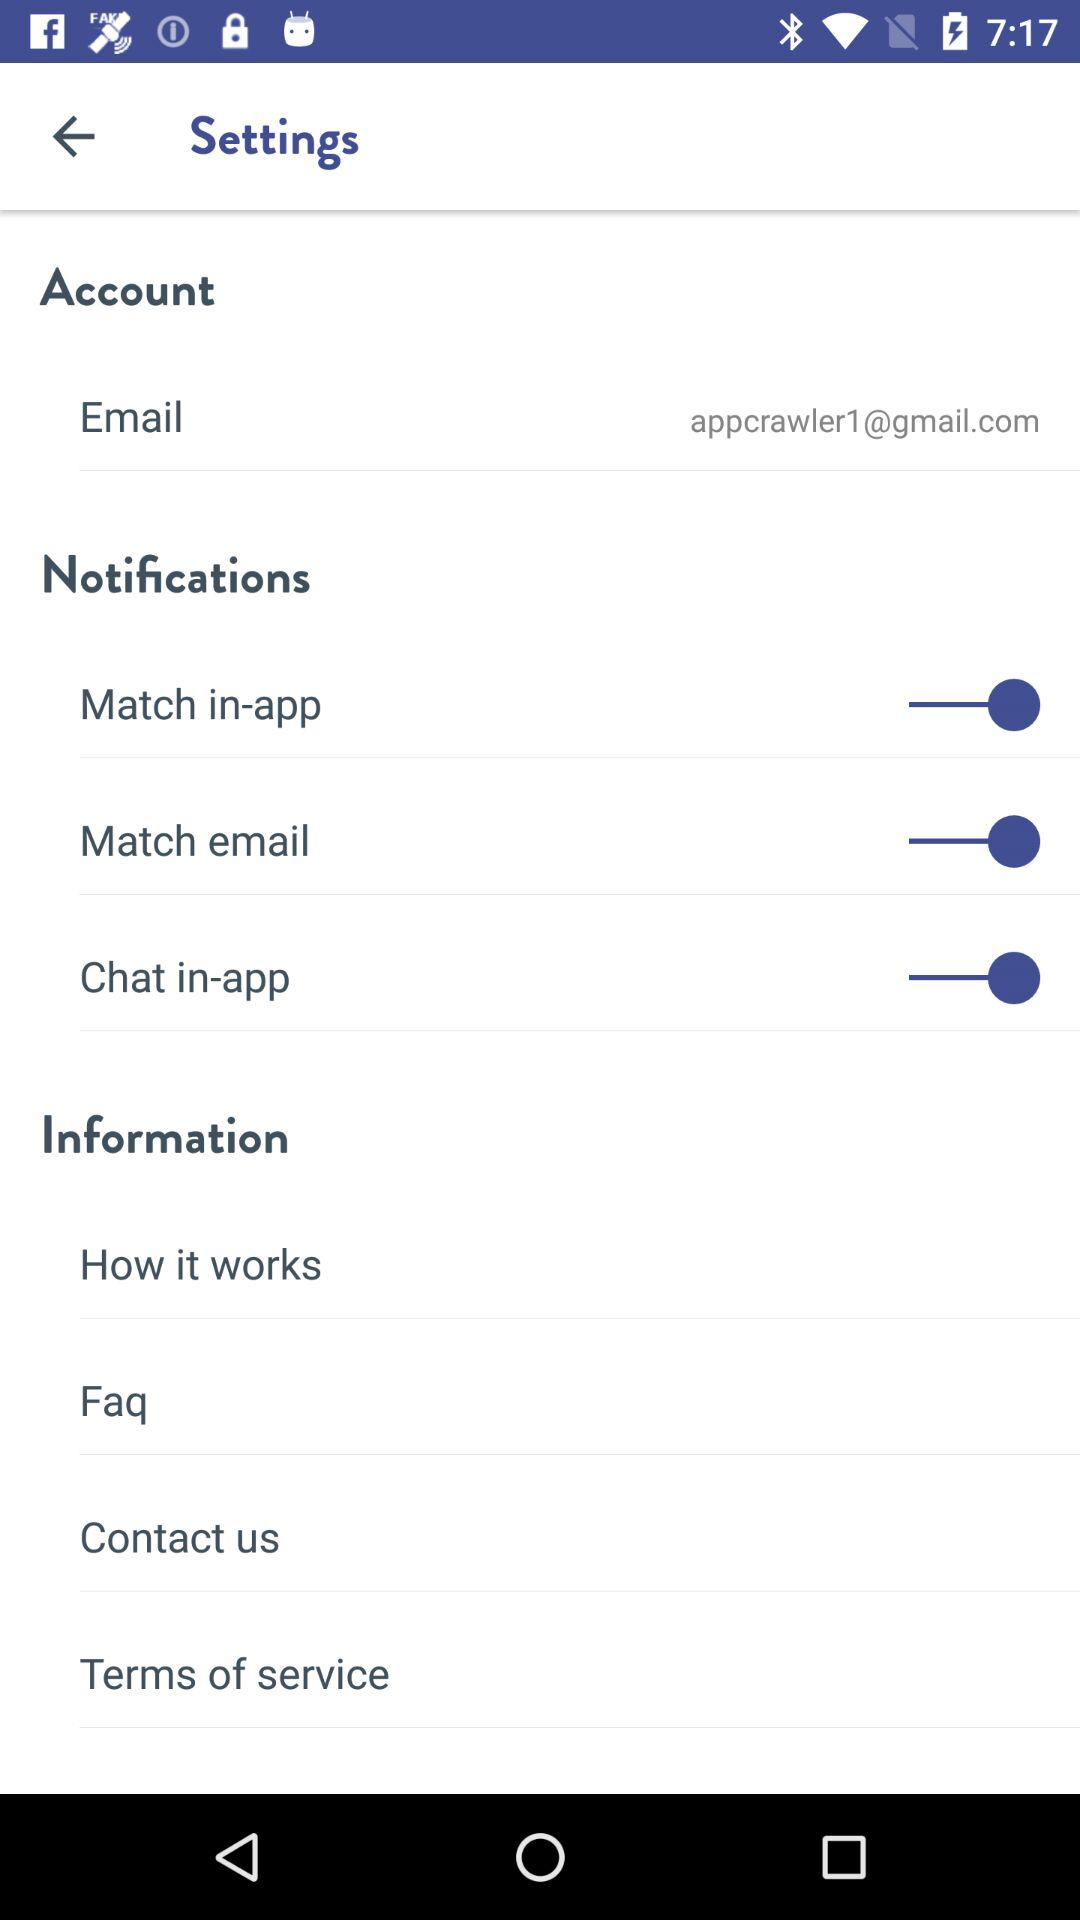What is the status of the "Chat in-app"? The status is "on". 